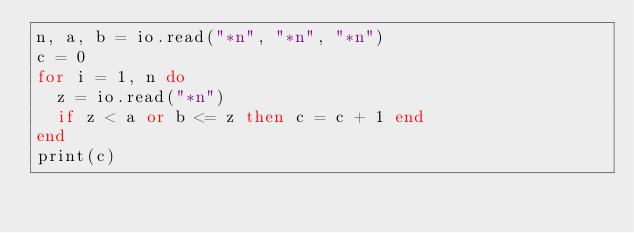<code> <loc_0><loc_0><loc_500><loc_500><_Lua_>n, a, b = io.read("*n", "*n", "*n")
c = 0
for i = 1, n do
  z = io.read("*n")
  if z < a or b <= z then c = c + 1 end
end
print(c)</code> 